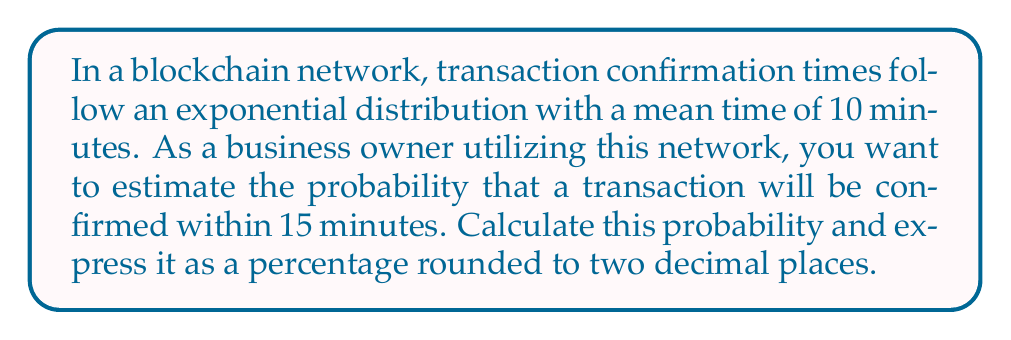Can you solve this math problem? Let's approach this step-by-step:

1) The exponential distribution is given by the probability density function:
   $$f(x) = \lambda e^{-\lambda x}$$
   where $\lambda$ is the rate parameter.

2) We're given that the mean time is 10 minutes. For an exponential distribution, the mean is equal to $\frac{1}{\lambda}$. So:
   $$\frac{1}{\lambda} = 10$$
   $$\lambda = \frac{1}{10} = 0.1$$

3) We want to find the probability that a transaction will be confirmed within 15 minutes. This is equivalent to finding the cumulative distribution function (CDF) at x = 15:
   $$P(X \leq 15) = 1 - e^{-\lambda x}$$

4) Substituting our values:
   $$P(X \leq 15) = 1 - e^{-0.1 * 15}$$

5) Calculating:
   $$P(X \leq 15) = 1 - e^{-1.5}$$
   $$P(X \leq 15) = 1 - 0.2231$$
   $$P(X \leq 15) = 0.7769$$

6) Converting to a percentage and rounding to two decimal places:
   $$0.7769 * 100 = 77.69\%$$
Answer: 77.69% 